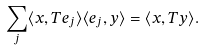Convert formula to latex. <formula><loc_0><loc_0><loc_500><loc_500>\sum _ { j } \langle x , T e _ { j } \rangle \langle e _ { j } , y \rangle = \langle x , T y \rangle .</formula> 